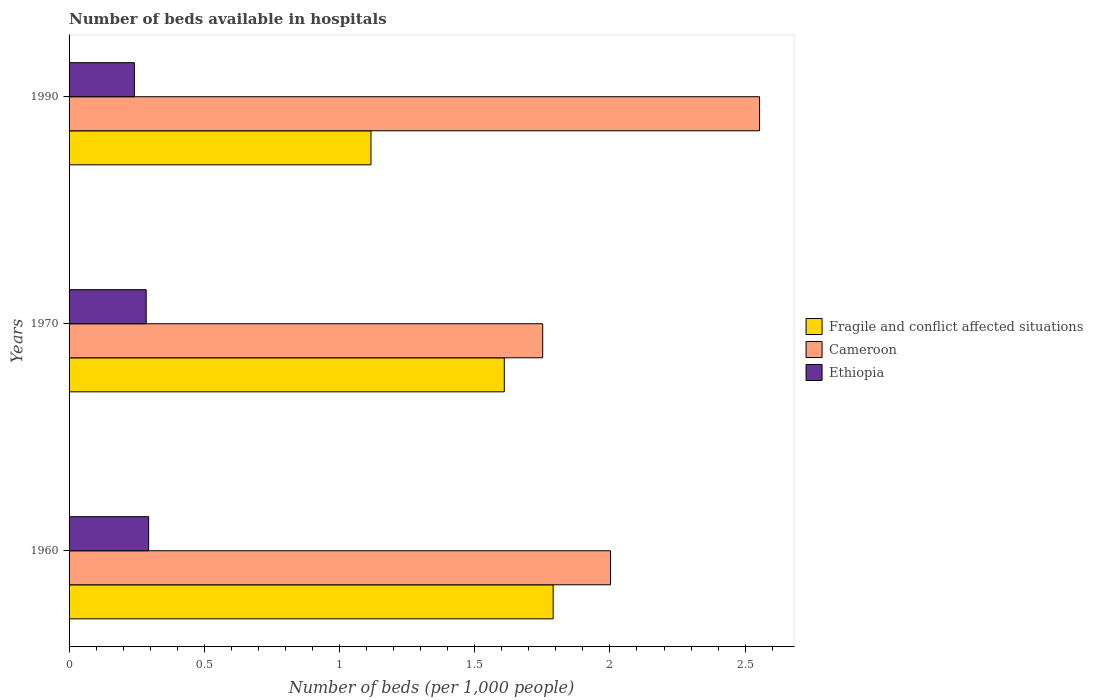How many different coloured bars are there?
Give a very brief answer. 3. How many groups of bars are there?
Offer a very short reply. 3. How many bars are there on the 2nd tick from the top?
Offer a terse response. 3. What is the label of the 1st group of bars from the top?
Offer a very short reply. 1990. What is the number of beds in the hospiatls of in Ethiopia in 1990?
Keep it short and to the point. 0.24. Across all years, what is the maximum number of beds in the hospiatls of in Ethiopia?
Your answer should be compact. 0.29. Across all years, what is the minimum number of beds in the hospiatls of in Fragile and conflict affected situations?
Provide a succinct answer. 1.12. In which year was the number of beds in the hospiatls of in Fragile and conflict affected situations maximum?
Offer a terse response. 1960. In which year was the number of beds in the hospiatls of in Fragile and conflict affected situations minimum?
Offer a terse response. 1990. What is the total number of beds in the hospiatls of in Ethiopia in the graph?
Give a very brief answer. 0.82. What is the difference between the number of beds in the hospiatls of in Cameroon in 1960 and that in 1990?
Give a very brief answer. -0.55. What is the difference between the number of beds in the hospiatls of in Fragile and conflict affected situations in 1990 and the number of beds in the hospiatls of in Ethiopia in 1970?
Give a very brief answer. 0.83. What is the average number of beds in the hospiatls of in Cameroon per year?
Your response must be concise. 2.1. In the year 1990, what is the difference between the number of beds in the hospiatls of in Fragile and conflict affected situations and number of beds in the hospiatls of in Ethiopia?
Provide a succinct answer. 0.87. What is the ratio of the number of beds in the hospiatls of in Cameroon in 1960 to that in 1970?
Make the answer very short. 1.14. What is the difference between the highest and the second highest number of beds in the hospiatls of in Ethiopia?
Provide a succinct answer. 0.01. What is the difference between the highest and the lowest number of beds in the hospiatls of in Fragile and conflict affected situations?
Keep it short and to the point. 0.67. Is the sum of the number of beds in the hospiatls of in Ethiopia in 1970 and 1990 greater than the maximum number of beds in the hospiatls of in Cameroon across all years?
Offer a very short reply. No. What does the 1st bar from the top in 1970 represents?
Offer a very short reply. Ethiopia. What does the 1st bar from the bottom in 1960 represents?
Ensure brevity in your answer.  Fragile and conflict affected situations. Is it the case that in every year, the sum of the number of beds in the hospiatls of in Ethiopia and number of beds in the hospiatls of in Fragile and conflict affected situations is greater than the number of beds in the hospiatls of in Cameroon?
Your answer should be compact. No. How many bars are there?
Your answer should be compact. 9. Are all the bars in the graph horizontal?
Keep it short and to the point. Yes. How many years are there in the graph?
Offer a very short reply. 3. What is the difference between two consecutive major ticks on the X-axis?
Make the answer very short. 0.5. Are the values on the major ticks of X-axis written in scientific E-notation?
Ensure brevity in your answer.  No. Does the graph contain any zero values?
Give a very brief answer. No. Where does the legend appear in the graph?
Offer a terse response. Center right. What is the title of the graph?
Give a very brief answer. Number of beds available in hospitals. What is the label or title of the X-axis?
Your answer should be very brief. Number of beds (per 1,0 people). What is the Number of beds (per 1,000 people) in Fragile and conflict affected situations in 1960?
Make the answer very short. 1.79. What is the Number of beds (per 1,000 people) in Cameroon in 1960?
Your answer should be very brief. 2. What is the Number of beds (per 1,000 people) in Ethiopia in 1960?
Provide a short and direct response. 0.29. What is the Number of beds (per 1,000 people) in Fragile and conflict affected situations in 1970?
Offer a very short reply. 1.61. What is the Number of beds (per 1,000 people) of Cameroon in 1970?
Provide a short and direct response. 1.75. What is the Number of beds (per 1,000 people) in Ethiopia in 1970?
Offer a terse response. 0.29. What is the Number of beds (per 1,000 people) of Fragile and conflict affected situations in 1990?
Provide a short and direct response. 1.12. What is the Number of beds (per 1,000 people) of Cameroon in 1990?
Make the answer very short. 2.55. What is the Number of beds (per 1,000 people) of Ethiopia in 1990?
Your answer should be very brief. 0.24. Across all years, what is the maximum Number of beds (per 1,000 people) of Fragile and conflict affected situations?
Offer a terse response. 1.79. Across all years, what is the maximum Number of beds (per 1,000 people) of Cameroon?
Offer a terse response. 2.55. Across all years, what is the maximum Number of beds (per 1,000 people) in Ethiopia?
Keep it short and to the point. 0.29. Across all years, what is the minimum Number of beds (per 1,000 people) of Fragile and conflict affected situations?
Provide a succinct answer. 1.12. Across all years, what is the minimum Number of beds (per 1,000 people) of Cameroon?
Offer a very short reply. 1.75. Across all years, what is the minimum Number of beds (per 1,000 people) of Ethiopia?
Offer a very short reply. 0.24. What is the total Number of beds (per 1,000 people) in Fragile and conflict affected situations in the graph?
Your response must be concise. 4.52. What is the total Number of beds (per 1,000 people) in Cameroon in the graph?
Offer a very short reply. 6.31. What is the total Number of beds (per 1,000 people) in Ethiopia in the graph?
Offer a terse response. 0.82. What is the difference between the Number of beds (per 1,000 people) in Fragile and conflict affected situations in 1960 and that in 1970?
Provide a succinct answer. 0.18. What is the difference between the Number of beds (per 1,000 people) in Cameroon in 1960 and that in 1970?
Keep it short and to the point. 0.25. What is the difference between the Number of beds (per 1,000 people) of Ethiopia in 1960 and that in 1970?
Provide a short and direct response. 0.01. What is the difference between the Number of beds (per 1,000 people) in Fragile and conflict affected situations in 1960 and that in 1990?
Provide a succinct answer. 0.67. What is the difference between the Number of beds (per 1,000 people) of Cameroon in 1960 and that in 1990?
Provide a succinct answer. -0.55. What is the difference between the Number of beds (per 1,000 people) in Ethiopia in 1960 and that in 1990?
Your response must be concise. 0.05. What is the difference between the Number of beds (per 1,000 people) in Fragile and conflict affected situations in 1970 and that in 1990?
Provide a succinct answer. 0.49. What is the difference between the Number of beds (per 1,000 people) of Cameroon in 1970 and that in 1990?
Make the answer very short. -0.8. What is the difference between the Number of beds (per 1,000 people) in Ethiopia in 1970 and that in 1990?
Offer a very short reply. 0.04. What is the difference between the Number of beds (per 1,000 people) of Fragile and conflict affected situations in 1960 and the Number of beds (per 1,000 people) of Cameroon in 1970?
Keep it short and to the point. 0.04. What is the difference between the Number of beds (per 1,000 people) in Fragile and conflict affected situations in 1960 and the Number of beds (per 1,000 people) in Ethiopia in 1970?
Keep it short and to the point. 1.5. What is the difference between the Number of beds (per 1,000 people) in Cameroon in 1960 and the Number of beds (per 1,000 people) in Ethiopia in 1970?
Your response must be concise. 1.72. What is the difference between the Number of beds (per 1,000 people) of Fragile and conflict affected situations in 1960 and the Number of beds (per 1,000 people) of Cameroon in 1990?
Give a very brief answer. -0.76. What is the difference between the Number of beds (per 1,000 people) of Fragile and conflict affected situations in 1960 and the Number of beds (per 1,000 people) of Ethiopia in 1990?
Offer a terse response. 1.55. What is the difference between the Number of beds (per 1,000 people) of Cameroon in 1960 and the Number of beds (per 1,000 people) of Ethiopia in 1990?
Provide a succinct answer. 1.76. What is the difference between the Number of beds (per 1,000 people) in Fragile and conflict affected situations in 1970 and the Number of beds (per 1,000 people) in Cameroon in 1990?
Keep it short and to the point. -0.94. What is the difference between the Number of beds (per 1,000 people) of Fragile and conflict affected situations in 1970 and the Number of beds (per 1,000 people) of Ethiopia in 1990?
Your response must be concise. 1.37. What is the difference between the Number of beds (per 1,000 people) in Cameroon in 1970 and the Number of beds (per 1,000 people) in Ethiopia in 1990?
Provide a succinct answer. 1.51. What is the average Number of beds (per 1,000 people) in Fragile and conflict affected situations per year?
Your answer should be compact. 1.51. What is the average Number of beds (per 1,000 people) in Cameroon per year?
Keep it short and to the point. 2.1. What is the average Number of beds (per 1,000 people) in Ethiopia per year?
Keep it short and to the point. 0.27. In the year 1960, what is the difference between the Number of beds (per 1,000 people) in Fragile and conflict affected situations and Number of beds (per 1,000 people) in Cameroon?
Your response must be concise. -0.21. In the year 1960, what is the difference between the Number of beds (per 1,000 people) of Fragile and conflict affected situations and Number of beds (per 1,000 people) of Ethiopia?
Offer a very short reply. 1.5. In the year 1960, what is the difference between the Number of beds (per 1,000 people) of Cameroon and Number of beds (per 1,000 people) of Ethiopia?
Make the answer very short. 1.71. In the year 1970, what is the difference between the Number of beds (per 1,000 people) of Fragile and conflict affected situations and Number of beds (per 1,000 people) of Cameroon?
Your answer should be compact. -0.14. In the year 1970, what is the difference between the Number of beds (per 1,000 people) of Fragile and conflict affected situations and Number of beds (per 1,000 people) of Ethiopia?
Ensure brevity in your answer.  1.32. In the year 1970, what is the difference between the Number of beds (per 1,000 people) of Cameroon and Number of beds (per 1,000 people) of Ethiopia?
Offer a terse response. 1.47. In the year 1990, what is the difference between the Number of beds (per 1,000 people) of Fragile and conflict affected situations and Number of beds (per 1,000 people) of Cameroon?
Provide a succinct answer. -1.44. In the year 1990, what is the difference between the Number of beds (per 1,000 people) in Fragile and conflict affected situations and Number of beds (per 1,000 people) in Ethiopia?
Give a very brief answer. 0.87. In the year 1990, what is the difference between the Number of beds (per 1,000 people) in Cameroon and Number of beds (per 1,000 people) in Ethiopia?
Provide a short and direct response. 2.31. What is the ratio of the Number of beds (per 1,000 people) in Fragile and conflict affected situations in 1960 to that in 1970?
Keep it short and to the point. 1.11. What is the ratio of the Number of beds (per 1,000 people) in Cameroon in 1960 to that in 1970?
Offer a very short reply. 1.14. What is the ratio of the Number of beds (per 1,000 people) in Ethiopia in 1960 to that in 1970?
Provide a short and direct response. 1.03. What is the ratio of the Number of beds (per 1,000 people) of Fragile and conflict affected situations in 1960 to that in 1990?
Offer a terse response. 1.6. What is the ratio of the Number of beds (per 1,000 people) of Cameroon in 1960 to that in 1990?
Make the answer very short. 0.78. What is the ratio of the Number of beds (per 1,000 people) of Ethiopia in 1960 to that in 1990?
Your answer should be compact. 1.22. What is the ratio of the Number of beds (per 1,000 people) of Fragile and conflict affected situations in 1970 to that in 1990?
Provide a succinct answer. 1.44. What is the ratio of the Number of beds (per 1,000 people) of Cameroon in 1970 to that in 1990?
Make the answer very short. 0.69. What is the ratio of the Number of beds (per 1,000 people) of Ethiopia in 1970 to that in 1990?
Provide a short and direct response. 1.18. What is the difference between the highest and the second highest Number of beds (per 1,000 people) of Fragile and conflict affected situations?
Your answer should be very brief. 0.18. What is the difference between the highest and the second highest Number of beds (per 1,000 people) of Cameroon?
Ensure brevity in your answer.  0.55. What is the difference between the highest and the second highest Number of beds (per 1,000 people) of Ethiopia?
Make the answer very short. 0.01. What is the difference between the highest and the lowest Number of beds (per 1,000 people) in Fragile and conflict affected situations?
Your response must be concise. 0.67. What is the difference between the highest and the lowest Number of beds (per 1,000 people) of Cameroon?
Offer a terse response. 0.8. What is the difference between the highest and the lowest Number of beds (per 1,000 people) in Ethiopia?
Provide a short and direct response. 0.05. 